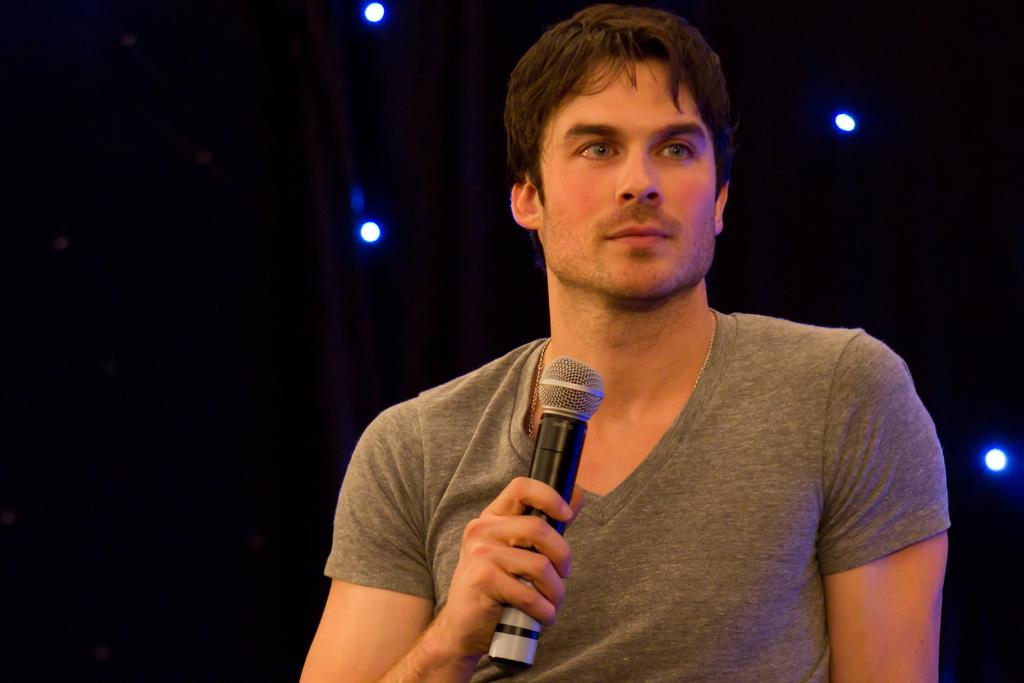Who is the main subject in the image? There is a man in the image. What is the man wearing? The man is wearing a grey t-shirt. What is the man holding in his right hand? The man is holding a mic in his right hand. What can be seen in the background of the image? There are lights in the background of the image. Where is the pig located in the image? There is no pig present in the image. What type of property is visible in the background of the image? There is no property visible in the image; only lights can be seen in the background. 